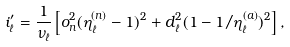Convert formula to latex. <formula><loc_0><loc_0><loc_500><loc_500>i ^ { \prime } _ { \ell } = \frac { 1 } { \nu _ { \ell } } \left [ o _ { n } ^ { 2 } ( \eta ^ { ( n ) } _ { \ell } - 1 ) ^ { 2 } + d _ { \ell } ^ { 2 } ( 1 - 1 / \eta ^ { ( a ) } _ { \ell } ) ^ { 2 } \right ] ,</formula> 